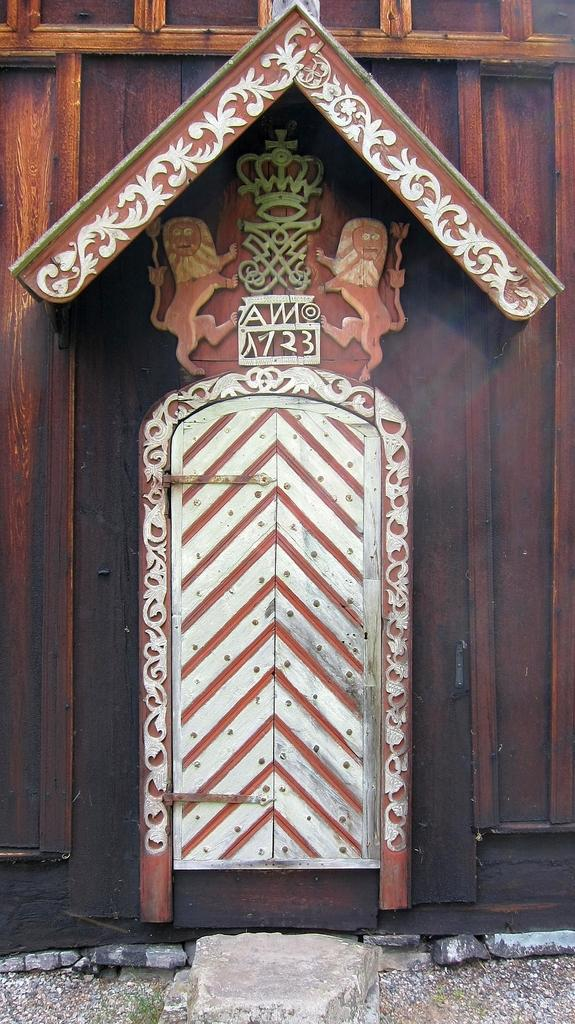What is the color of the gate in the image? The gate in the image is white. What type of wall is present in the image? There is a brown color wooden wall in the image. Are there any decorative features on the wooden wall? Yes, the wooden wall has carvings on it. What type of material is the stone placed on the land made of? The stone placed on the land is made of stone. Who is the manager of the grass in the image? There is no grass present in the image, so there is no manager for it. What type of joke is being told by the stone in the image? There is no joke being told by the stone in the image; it is a stationary object made of stone. 